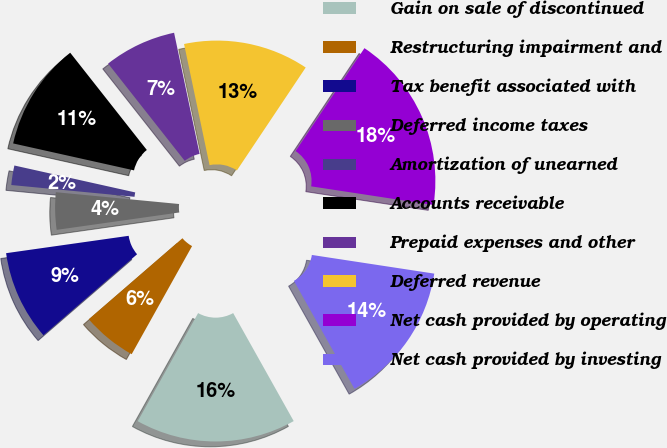<chart> <loc_0><loc_0><loc_500><loc_500><pie_chart><fcel>Gain on sale of discontinued<fcel>Restructuring impairment and<fcel>Tax benefit associated with<fcel>Deferred income taxes<fcel>Amortization of unearned<fcel>Accounts receivable<fcel>Prepaid expenses and other<fcel>Deferred revenue<fcel>Net cash provided by operating<fcel>Net cash provided by investing<nl><fcel>16.24%<fcel>5.54%<fcel>9.11%<fcel>3.76%<fcel>1.97%<fcel>10.89%<fcel>7.32%<fcel>12.68%<fcel>18.03%<fcel>14.46%<nl></chart> 